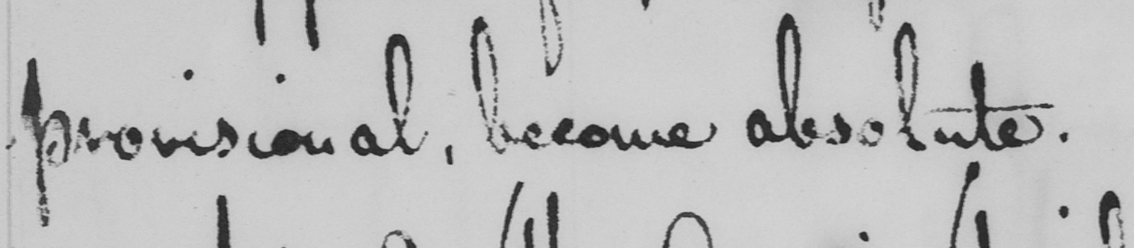What text is written in this handwritten line? provisional, become absolute. 